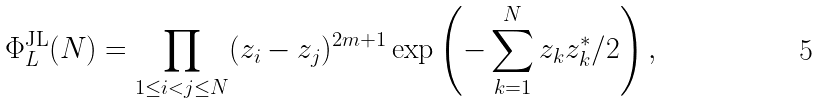Convert formula to latex. <formula><loc_0><loc_0><loc_500><loc_500>\Phi ^ { \text {JL} } _ { L } ( N ) = \prod _ { 1 \leq i < j \leq N } ( z _ { i } - z _ { j } ) ^ { 2 m + 1 } \exp \left ( - \sum _ { k = 1 } ^ { N } z _ { k } z _ { k } ^ { * } / 2 \right ) ,</formula> 